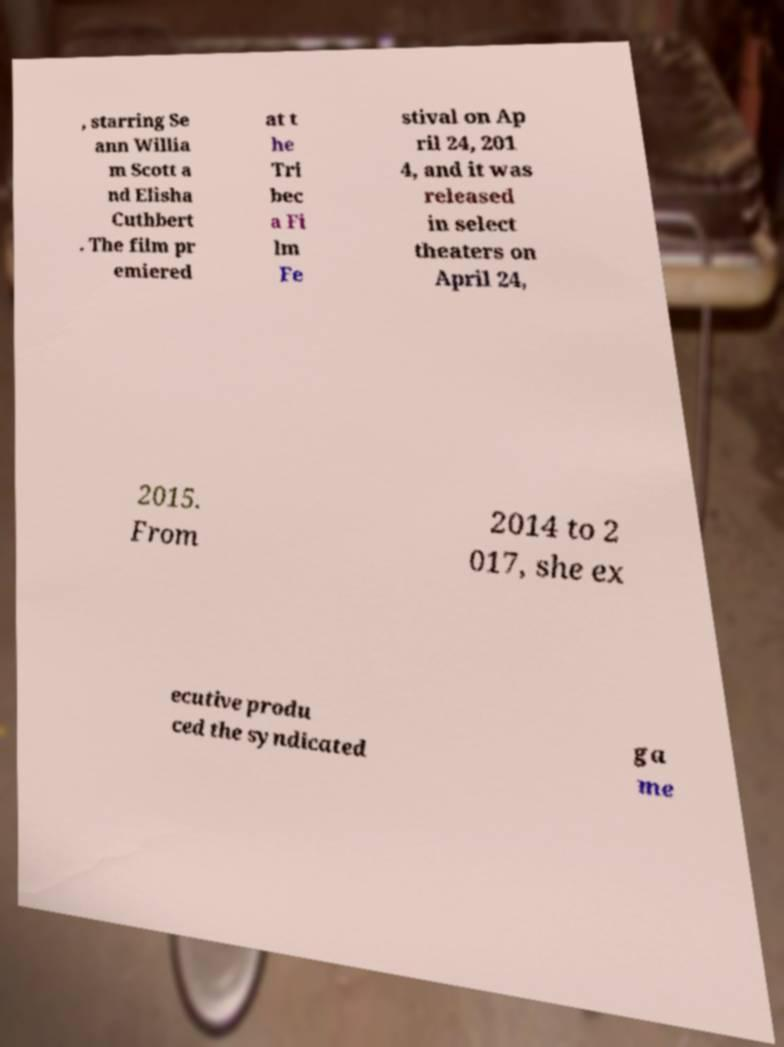Can you read and provide the text displayed in the image?This photo seems to have some interesting text. Can you extract and type it out for me? , starring Se ann Willia m Scott a nd Elisha Cuthbert . The film pr emiered at t he Tri bec a Fi lm Fe stival on Ap ril 24, 201 4, and it was released in select theaters on April 24, 2015. From 2014 to 2 017, she ex ecutive produ ced the syndicated ga me 